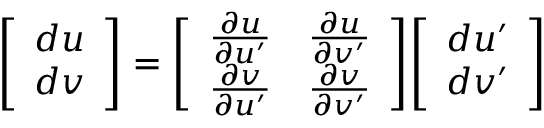Convert formula to latex. <formula><loc_0><loc_0><loc_500><loc_500>{ \left [ \begin{array} { l } { d u } \\ { d v } \end{array} \right ] } = { \left [ \begin{array} { l l } { { \frac { \partial u } { \partial u ^ { \prime } } } } & { { \frac { \partial u } { \partial v ^ { \prime } } } } \\ { { \frac { \partial v } { \partial u ^ { \prime } } } } & { { \frac { \partial v } { \partial v ^ { \prime } } } } \end{array} \right ] } { \left [ \begin{array} { l } { d u ^ { \prime } } \\ { d v ^ { \prime } } \end{array} \right ] }</formula> 